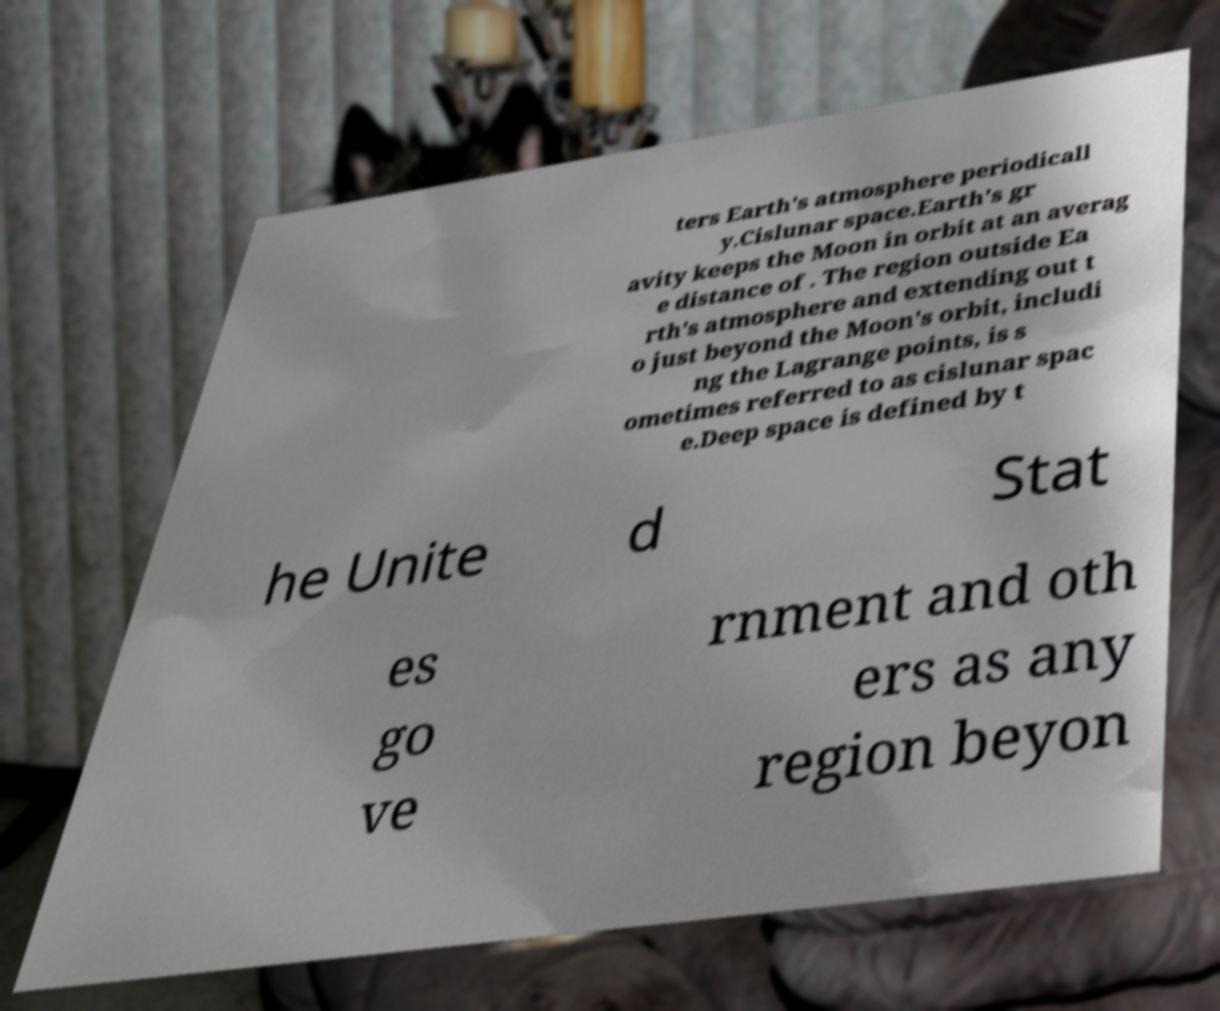Could you extract and type out the text from this image? ters Earth's atmosphere periodicall y.Cislunar space.Earth's gr avity keeps the Moon in orbit at an averag e distance of . The region outside Ea rth's atmosphere and extending out t o just beyond the Moon's orbit, includi ng the Lagrange points, is s ometimes referred to as cislunar spac e.Deep space is defined by t he Unite d Stat es go ve rnment and oth ers as any region beyon 